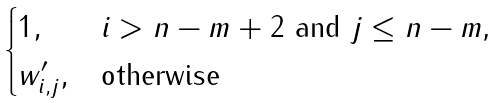Convert formula to latex. <formula><loc_0><loc_0><loc_500><loc_500>\begin{cases} 1 , & \text {$i>n-m+2$ and $j\leq n-m$,} \\ w ^ { \prime } _ { i , j } , & \text {otherwise} \end{cases}</formula> 